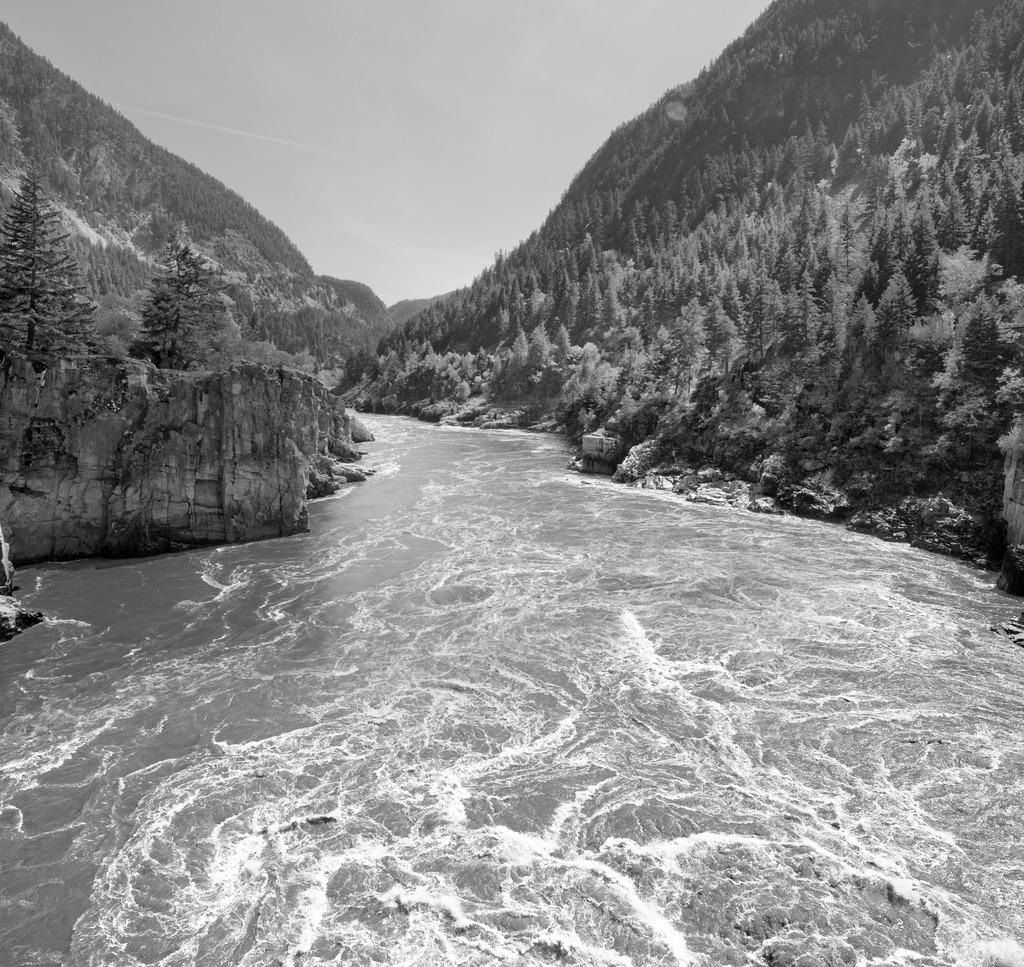What is one of the main elements in the image? There is water in the image. What other natural features can be seen in the image? There are trees and mountains in the image. What part of the sky is visible in the image? The sky is visible in the image. Can you make an assumption about the time of day based on the image? The image might have been taken during the day, as there is sufficient light to see the water, trees, mountains, and sky. Can you see a scarf hanging from one of the trees in the image? There is no scarf present in the image; only water, trees, mountains, and sky are visible. Is there a giraffe grazing near the water in the image? There is no giraffe present in the image; the natural features visible are water, trees, and mountains. 